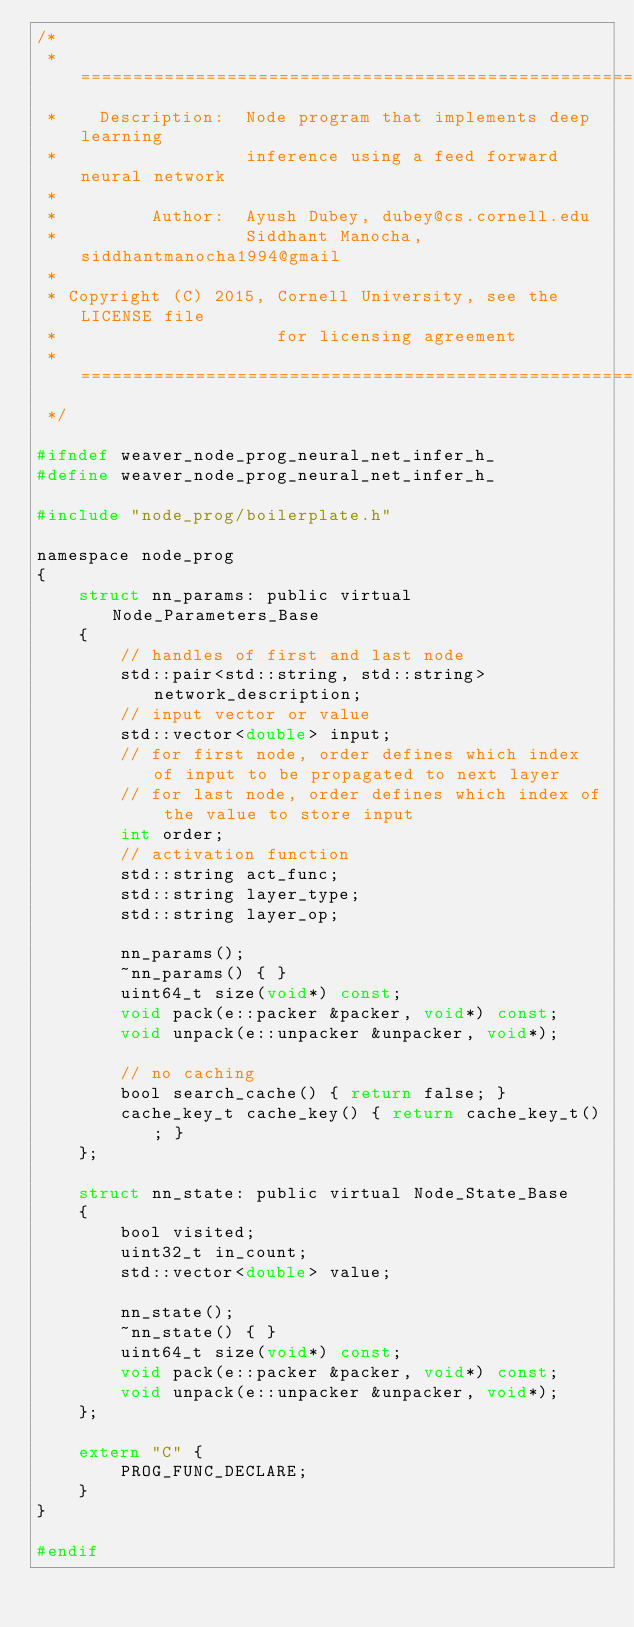<code> <loc_0><loc_0><loc_500><loc_500><_C_>/*
 * ===============================================================
 *    Description:  Node program that implements deep learning
 *                  inference using a feed forward neural network
 *
 *         Author:  Ayush Dubey, dubey@cs.cornell.edu
 *                  Siddhant Manocha, siddhantmanocha1994@gmail
 *
 * Copyright (C) 2015, Cornell University, see the LICENSE file
 *                     for licensing agreement
 * ===============================================================
 */

#ifndef weaver_node_prog_neural_net_infer_h_
#define weaver_node_prog_neural_net_infer_h_

#include "node_prog/boilerplate.h"

namespace node_prog
{
    struct nn_params: public virtual Node_Parameters_Base
    {
        // handles of first and last node
        std::pair<std::string, std::string> network_description;
        // input vector or value
        std::vector<double> input;
        // for first node, order defines which index of input to be propagated to next layer
        // for last node, order defines which index of the value to store input
        int order;
        // activation function
        std::string act_func;
        std::string layer_type;
        std::string layer_op;

        nn_params();
        ~nn_params() { }
        uint64_t size(void*) const;
        void pack(e::packer &packer, void*) const;
        void unpack(e::unpacker &unpacker, void*);

        // no caching
        bool search_cache() { return false; }
        cache_key_t cache_key() { return cache_key_t(); }
    };

    struct nn_state: public virtual Node_State_Base
    {
        bool visited;
        uint32_t in_count;
        std::vector<double> value;

        nn_state();
        ~nn_state() { }
        uint64_t size(void*) const;
        void pack(e::packer &packer, void*) const;
        void unpack(e::unpacker &unpacker, void*);
    };

    extern "C" {
        PROG_FUNC_DECLARE;
    }
}

#endif
</code> 